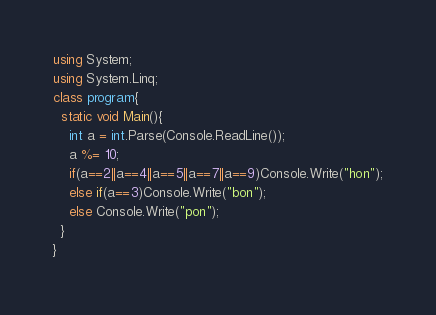<code> <loc_0><loc_0><loc_500><loc_500><_C#_>using System;
using System.Linq;
class program{
  static void Main(){
    int a = int.Parse(Console.ReadLine());
    a %= 10;
    if(a==2||a==4||a==5||a==7||a==9)Console.Write("hon");
    else if(a==3)Console.Write("bon");
    else Console.Write("pon");
  }
}</code> 